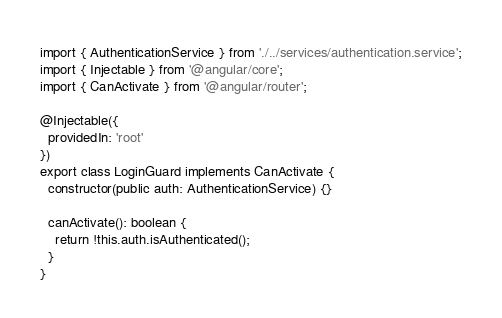<code> <loc_0><loc_0><loc_500><loc_500><_TypeScript_>import { AuthenticationService } from './../services/authentication.service';
import { Injectable } from '@angular/core';
import { CanActivate } from '@angular/router';

@Injectable({
  providedIn: 'root'
})
export class LoginGuard implements CanActivate {
  constructor(public auth: AuthenticationService) {}

  canActivate(): boolean {
    return !this.auth.isAuthenticated();
  }
}
</code> 